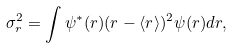<formula> <loc_0><loc_0><loc_500><loc_500>\sigma _ { r } ^ { 2 } = \int \psi ^ { * } ( r ) ( r - \langle r \rangle ) ^ { 2 } \psi ( r ) d r ,</formula> 